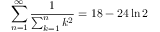Convert formula to latex. <formula><loc_0><loc_0><loc_500><loc_500>\sum _ { n = 1 } ^ { \infty } { \frac { 1 } { \sum _ { k = 1 } ^ { n } k ^ { 2 } } } = 1 8 - 2 4 \ln 2</formula> 